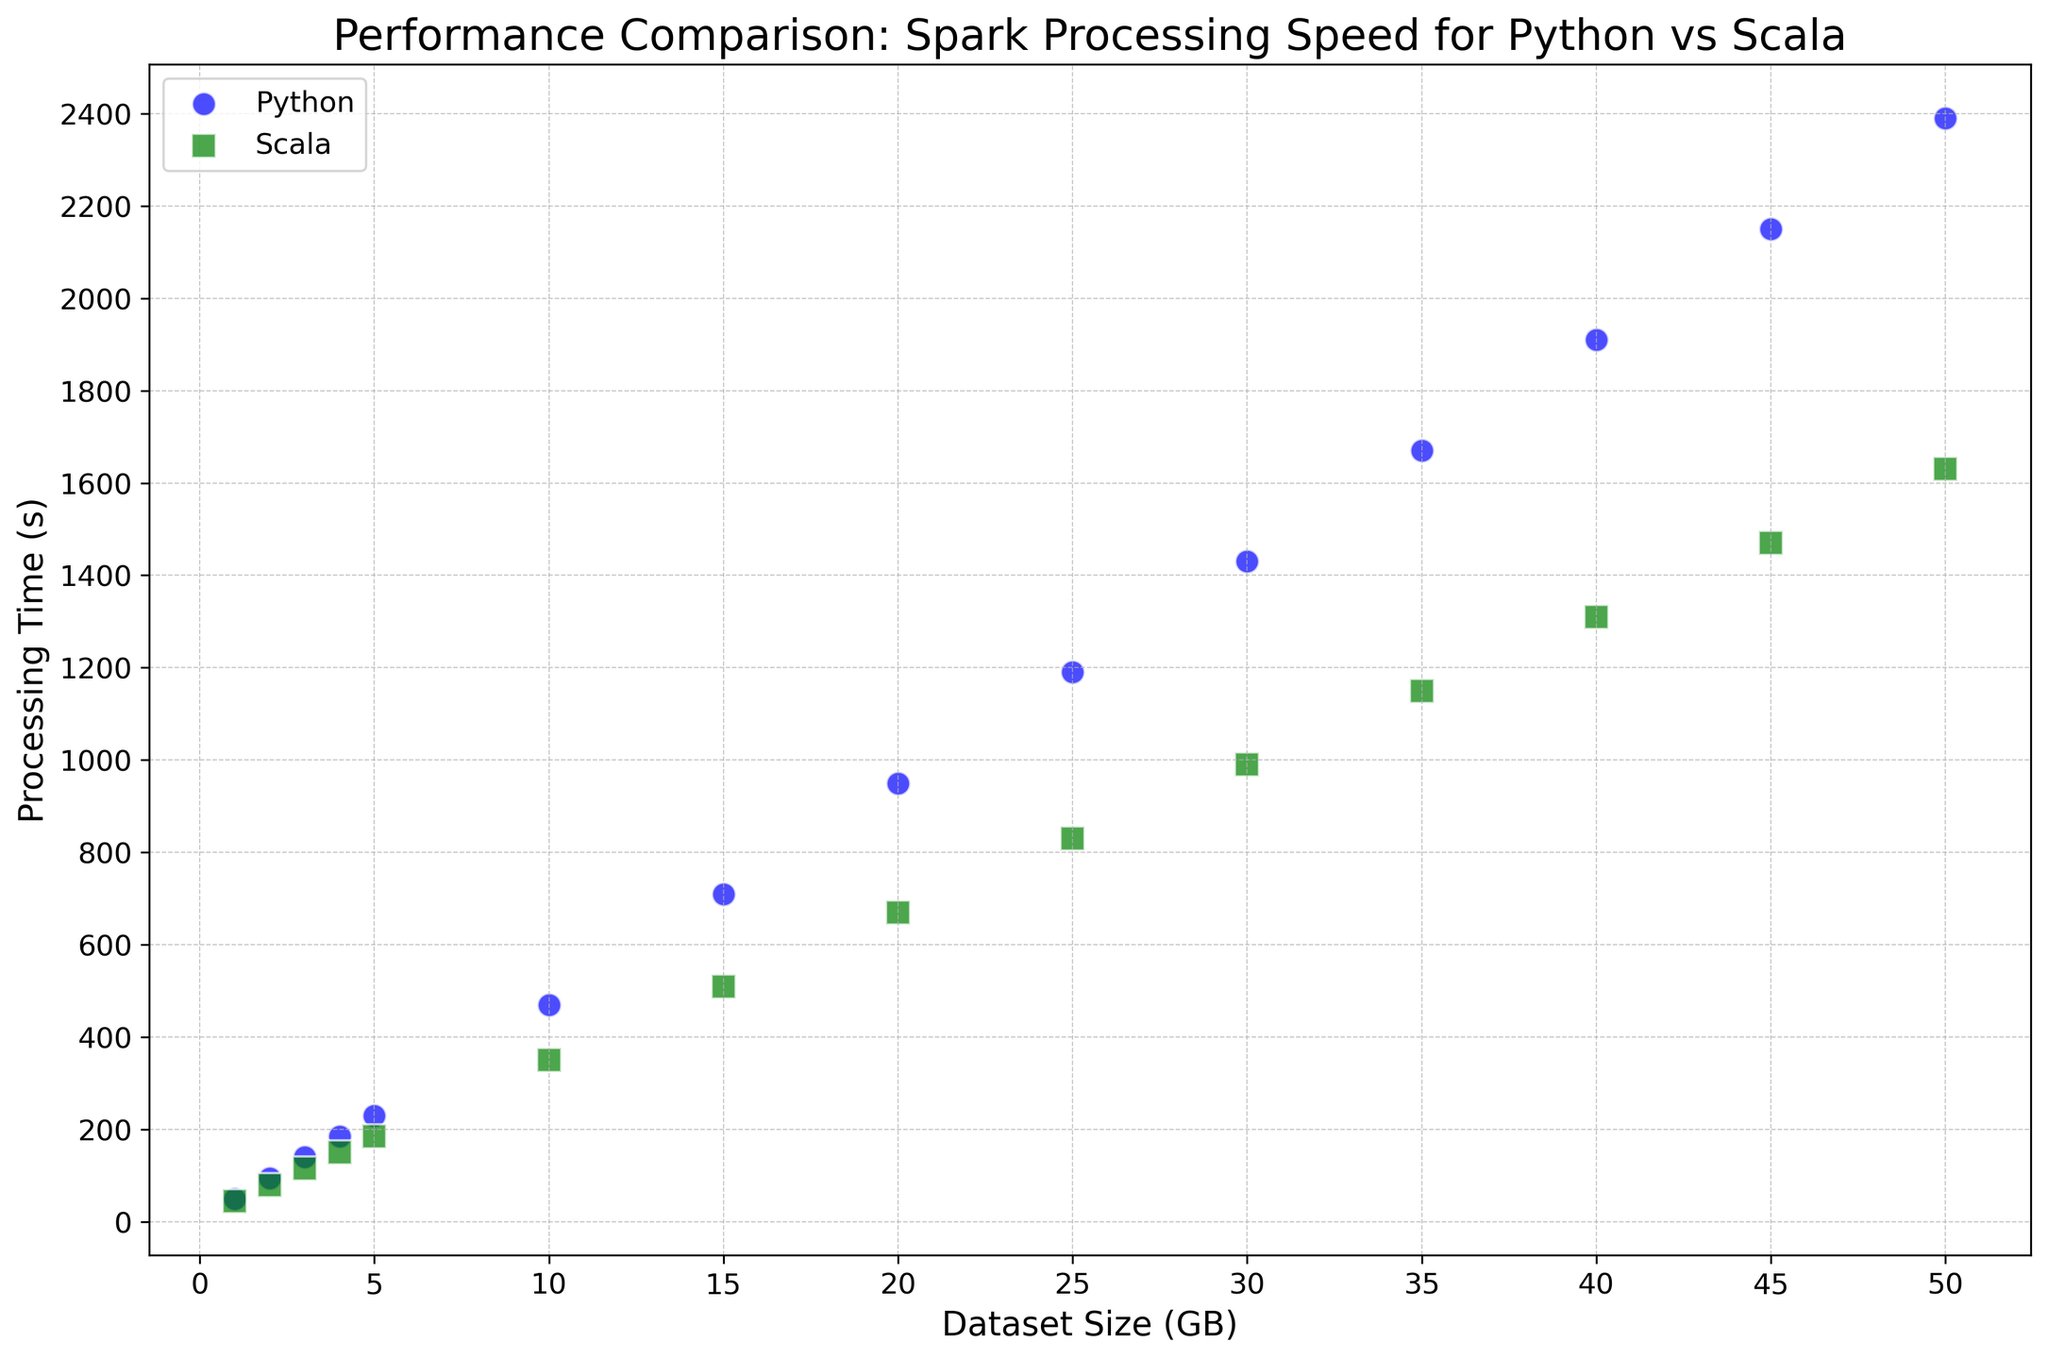What's the approximate difference in processing time between Python and Scala for a dataset size of 10 GB? To find the difference in processing times for a 10 GB dataset, identify the Python processing time (470 seconds) and Scala processing time (350 seconds). Subtract 350 from 470 to get the difference.
Answer: 120 seconds At what dataset size does the gap in processing time between Python and Scala first exceed 200 seconds? Observe the dataset sizes and calculate the difference in corresponding processing times. At 15 GB, Python takes 710 seconds and Scala takes 510 seconds. The difference here is 200 seconds. At 20 GB, Python takes 950 seconds and Scala takes 670 seconds, which is a difference of 280 seconds. Thus, the gap first exceeds 200 seconds at 20 GB.
Answer: 20 GB How does the trend in processing time differ between Python and Scala as the dataset size increases? As the dataset size increases, both Python and Scala show an upward trend in processing times. However, the Python processing time increases at a higher rate compared to Scala, indicating that Scala scales better with larger datasets.
Answer: Scala scales better What is the processing time for Python for a dataset size of 30 GB? Locate the point corresponding to the 30 GB dataset size on the x-axis and trace it to the y-axis for Python processing time. The processing time for Python at 30 GB is 1430 seconds.
Answer: 1430 seconds Which implementation (Python or Scala) shows a more consistent increase in processing time as the dataset size grows? Consistency in processing time can be judged by observing the scatter plot points. Scala's points form a smoother, more consistent line compared to Python's, suggesting Scala has a more steady increase in processing time as dataset size increases.
Answer: Scala What can be inferred about the processing speeds at smaller dataset sizes (1-5 GB)? At smaller dataset sizes (1-5 GB), the processing times for both Python and Scala are relatively close, with Scala having a slight advantage. This suggests that the overhead differences between Python and Scala are less pronounced with smaller datasets.
Answer: Processing times are close; Scala slightly faster Is there any trend in the relationship between dataset size and processing time? Both Python and Scala processing times increase roughly linearly with dataset size, indicating a direct relationship where larger datasets require proportionally more processing time.
Answer: Linear increase 